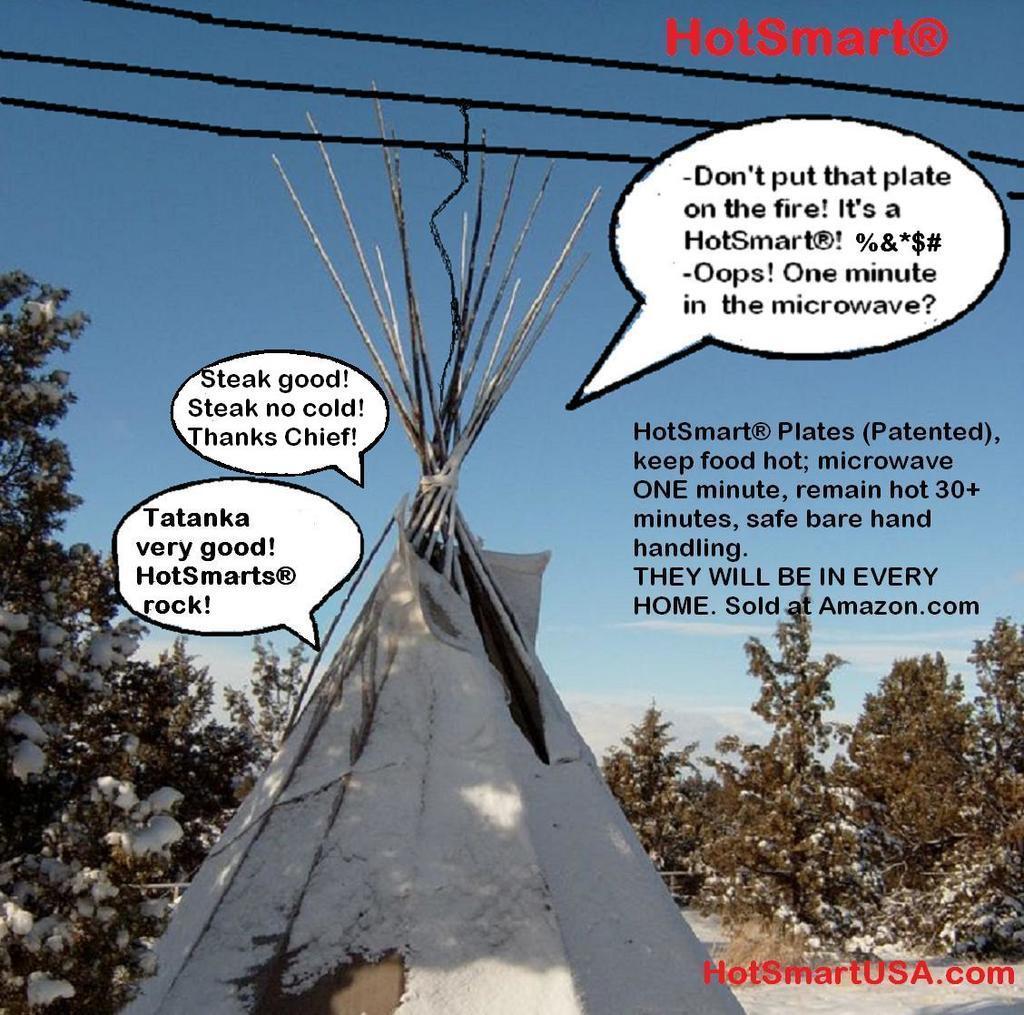Can you describe this image briefly? In this image, there is snow. There are trees at the down side of an image. At the top it is the sky, there are texts in this image. 